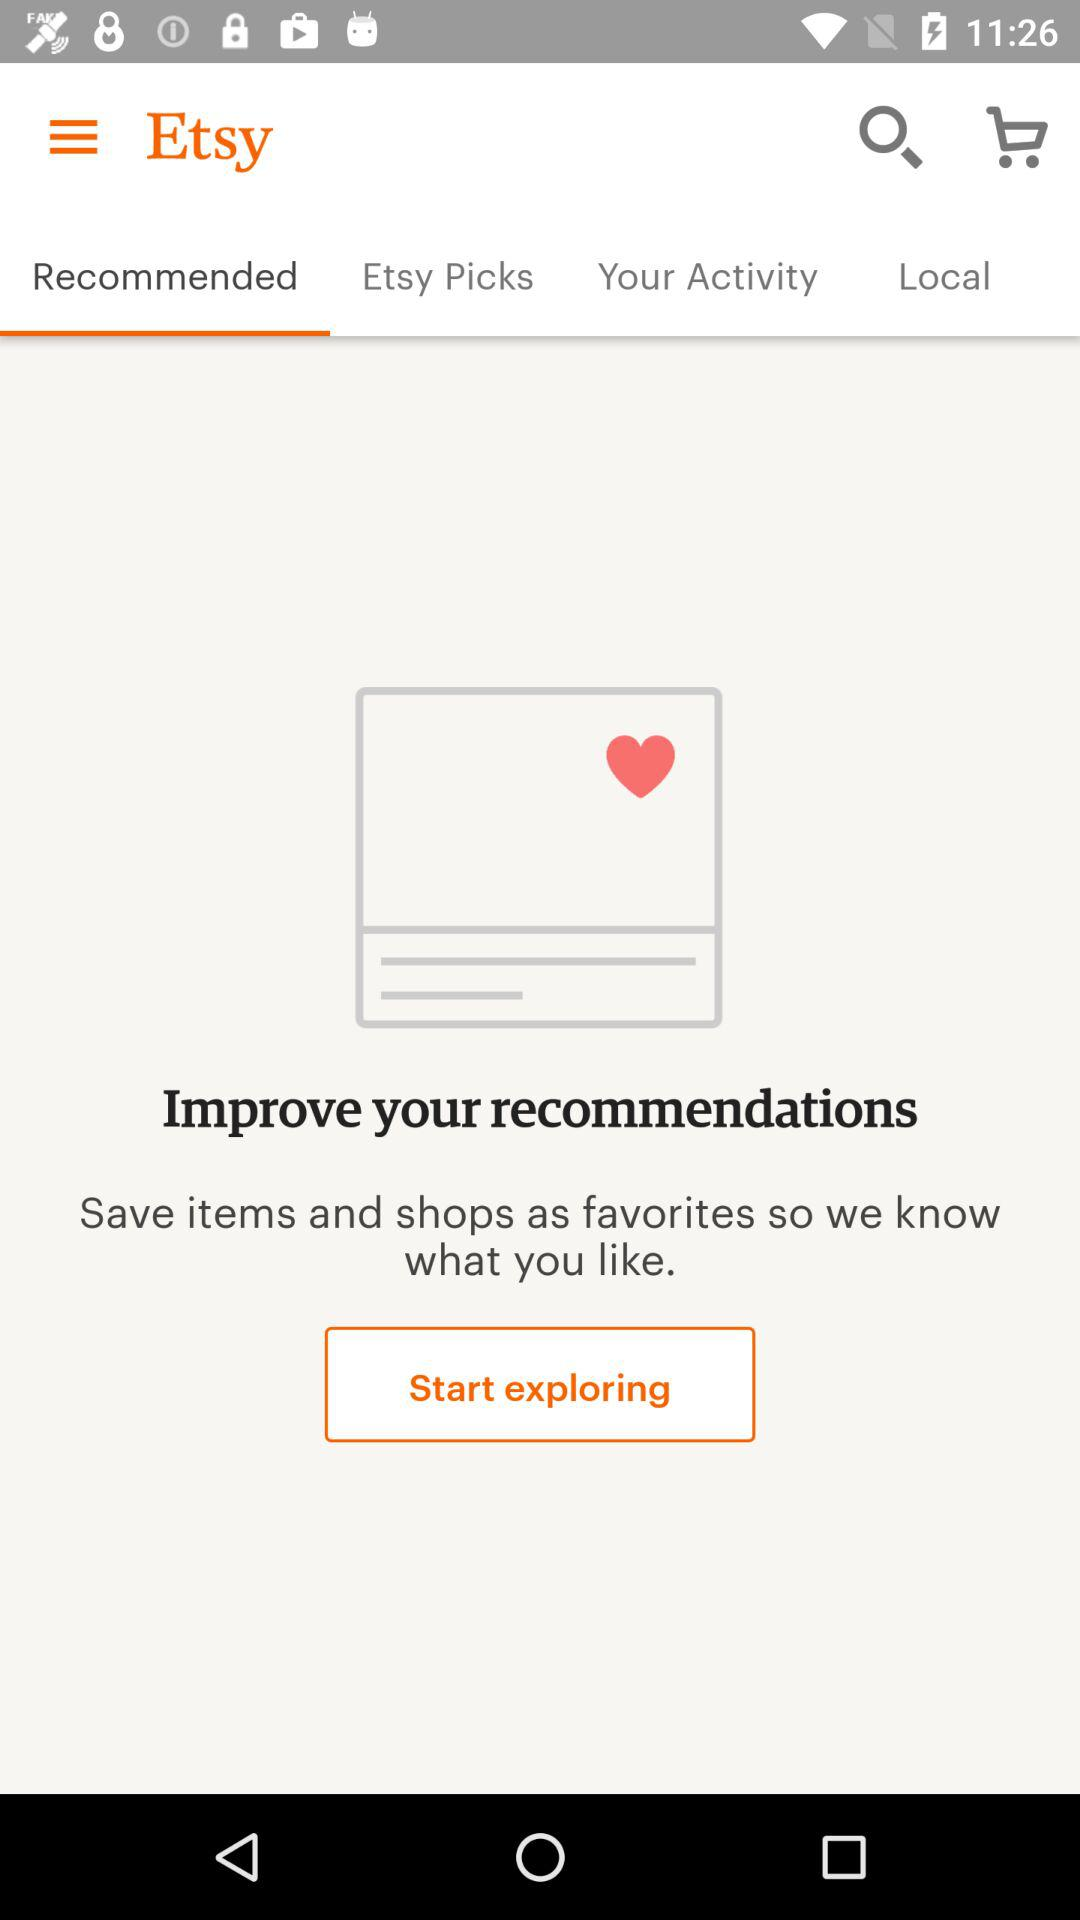What is the application name? The application name is "Etsy". 